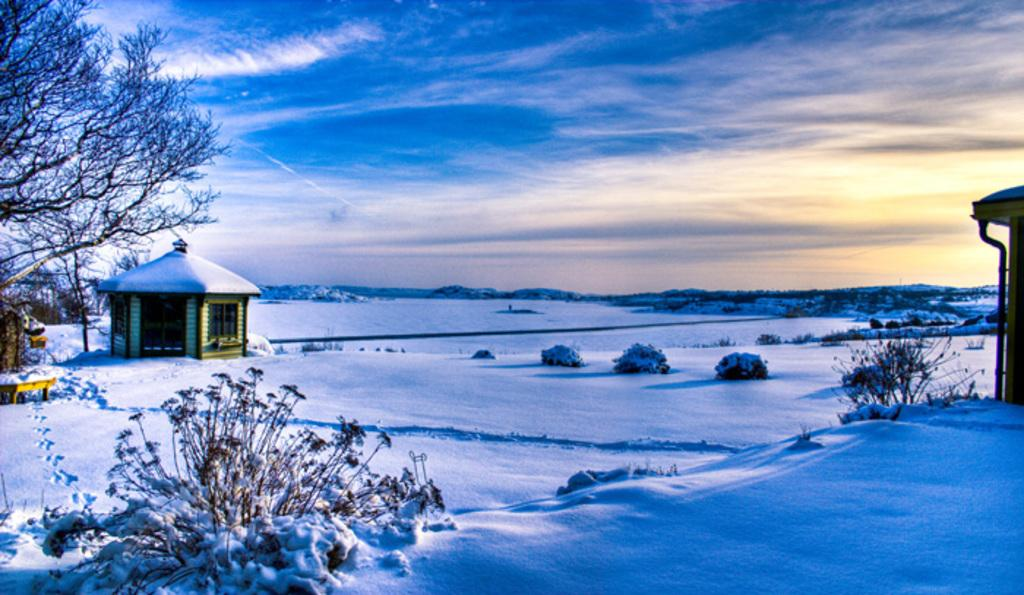What type of vegetation can be seen in the image? There are plants in the image. What is the weather condition in the image? There is snow visible in the image. What type of structures are present in the image? There are sheds in the image. What type of natural scenery is visible in the image? There are trees in the image. What is visible behind the trees in the image? The sky is visible behind the trees in the image. What type of anger is being displayed by the plants in the image? There is no anger displayed by the plants in the image, as plants do not have emotions. What type of sack is being used to carry the snow in the image? There is no sack present in the image, and the snow is not being carried by any object or person. 